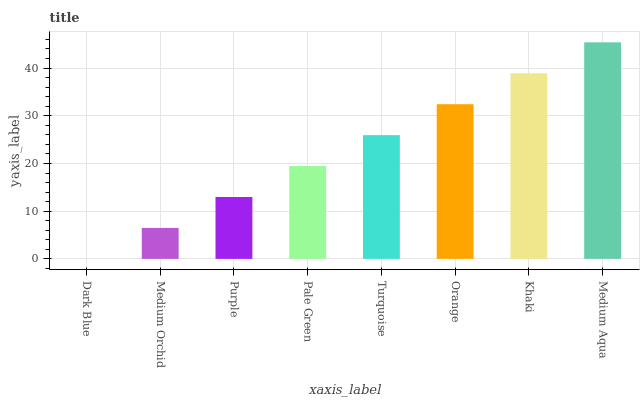Is Dark Blue the minimum?
Answer yes or no. Yes. Is Medium Aqua the maximum?
Answer yes or no. Yes. Is Medium Orchid the minimum?
Answer yes or no. No. Is Medium Orchid the maximum?
Answer yes or no. No. Is Medium Orchid greater than Dark Blue?
Answer yes or no. Yes. Is Dark Blue less than Medium Orchid?
Answer yes or no. Yes. Is Dark Blue greater than Medium Orchid?
Answer yes or no. No. Is Medium Orchid less than Dark Blue?
Answer yes or no. No. Is Turquoise the high median?
Answer yes or no. Yes. Is Pale Green the low median?
Answer yes or no. Yes. Is Medium Aqua the high median?
Answer yes or no. No. Is Medium Aqua the low median?
Answer yes or no. No. 